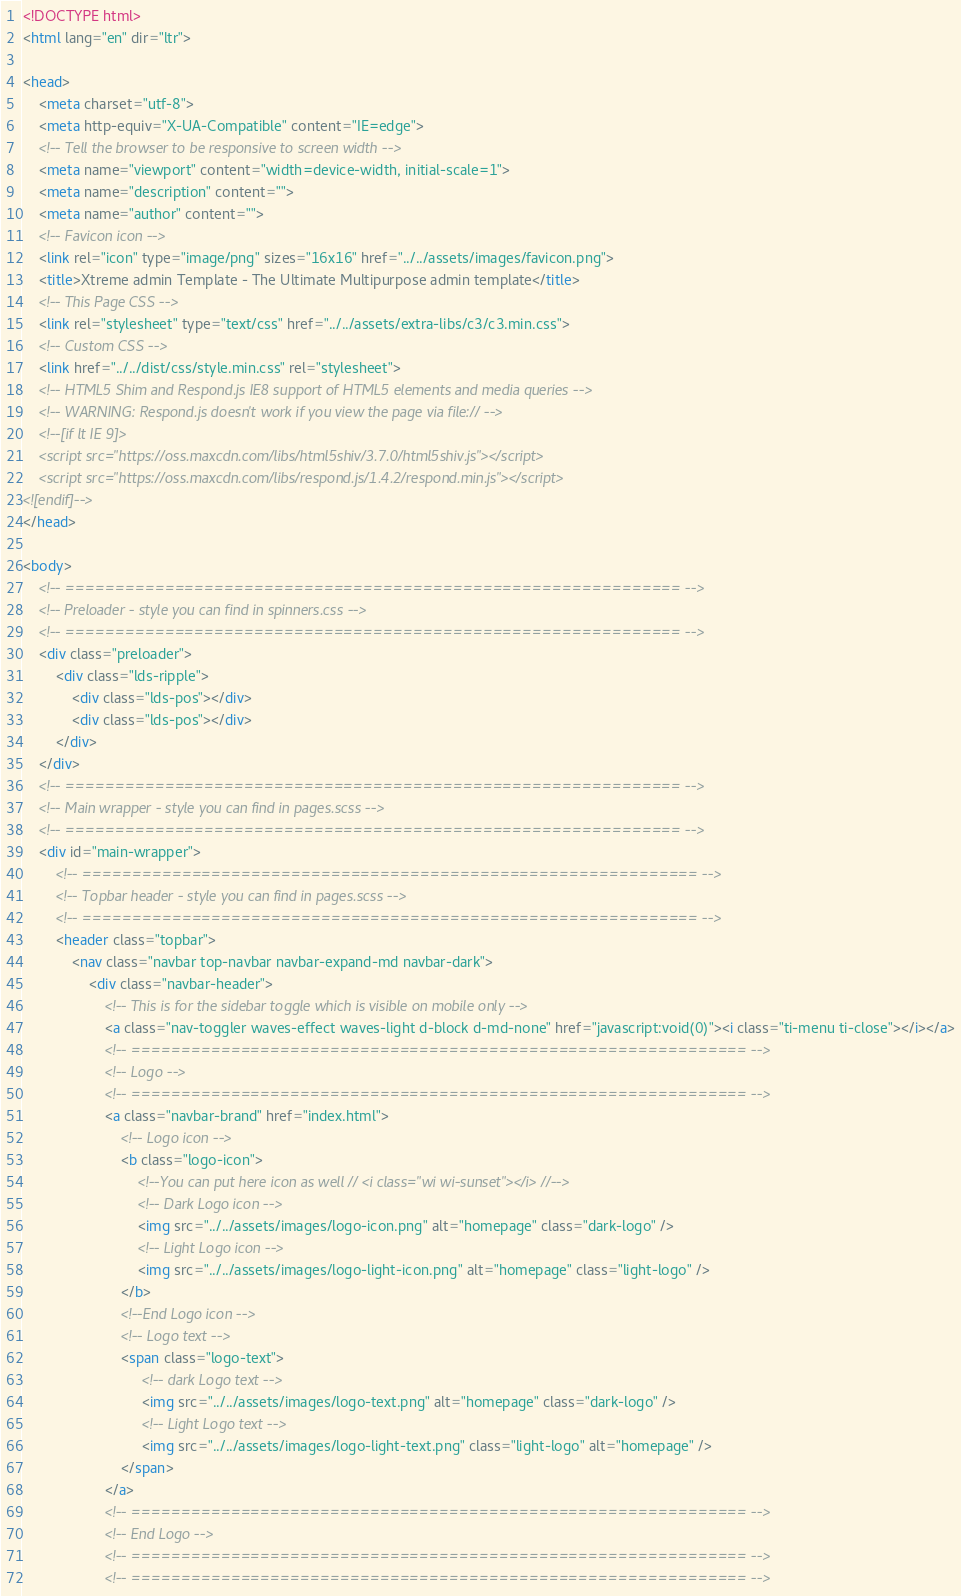<code> <loc_0><loc_0><loc_500><loc_500><_HTML_><!DOCTYPE html>
<html lang="en" dir="ltr">

<head>
    <meta charset="utf-8">
    <meta http-equiv="X-UA-Compatible" content="IE=edge">
    <!-- Tell the browser to be responsive to screen width -->
    <meta name="viewport" content="width=device-width, initial-scale=1">
    <meta name="description" content="">
    <meta name="author" content="">
    <!-- Favicon icon -->
    <link rel="icon" type="image/png" sizes="16x16" href="../../assets/images/favicon.png">
    <title>Xtreme admin Template - The Ultimate Multipurpose admin template</title>
    <!-- This Page CSS -->
    <link rel="stylesheet" type="text/css" href="../../assets/extra-libs/c3/c3.min.css">
    <!-- Custom CSS -->
    <link href="../../dist/css/style.min.css" rel="stylesheet">
    <!-- HTML5 Shim and Respond.js IE8 support of HTML5 elements and media queries -->
    <!-- WARNING: Respond.js doesn't work if you view the page via file:// -->
    <!--[if lt IE 9]>
    <script src="https://oss.maxcdn.com/libs/html5shiv/3.7.0/html5shiv.js"></script>
    <script src="https://oss.maxcdn.com/libs/respond.js/1.4.2/respond.min.js"></script>
<![endif]-->
</head>

<body>
    <!-- ============================================================== -->
    <!-- Preloader - style you can find in spinners.css -->
    <!-- ============================================================== -->
    <div class="preloader">
        <div class="lds-ripple">
            <div class="lds-pos"></div>
            <div class="lds-pos"></div>
        </div>
    </div>
    <!-- ============================================================== -->
    <!-- Main wrapper - style you can find in pages.scss -->
    <!-- ============================================================== -->
    <div id="main-wrapper">
        <!-- ============================================================== -->
        <!-- Topbar header - style you can find in pages.scss -->
        <!-- ============================================================== -->
        <header class="topbar">
            <nav class="navbar top-navbar navbar-expand-md navbar-dark">
                <div class="navbar-header">
                    <!-- This is for the sidebar toggle which is visible on mobile only -->
                    <a class="nav-toggler waves-effect waves-light d-block d-md-none" href="javascript:void(0)"><i class="ti-menu ti-close"></i></a>
                    <!-- ============================================================== -->
                    <!-- Logo -->
                    <!-- ============================================================== -->
                    <a class="navbar-brand" href="index.html">
                        <!-- Logo icon -->
                        <b class="logo-icon">
                            <!--You can put here icon as well // <i class="wi wi-sunset"></i> //-->
                            <!-- Dark Logo icon -->
                            <img src="../../assets/images/logo-icon.png" alt="homepage" class="dark-logo" />
                            <!-- Light Logo icon -->
                            <img src="../../assets/images/logo-light-icon.png" alt="homepage" class="light-logo" />
                        </b>
                        <!--End Logo icon -->
                        <!-- Logo text -->
                        <span class="logo-text">
                             <!-- dark Logo text -->
                             <img src="../../assets/images/logo-text.png" alt="homepage" class="dark-logo" />
                             <!-- Light Logo text -->    
                             <img src="../../assets/images/logo-light-text.png" class="light-logo" alt="homepage" />
                        </span>
                    </a>
                    <!-- ============================================================== -->
                    <!-- End Logo -->
                    <!-- ============================================================== -->
                    <!-- ============================================================== --></code> 